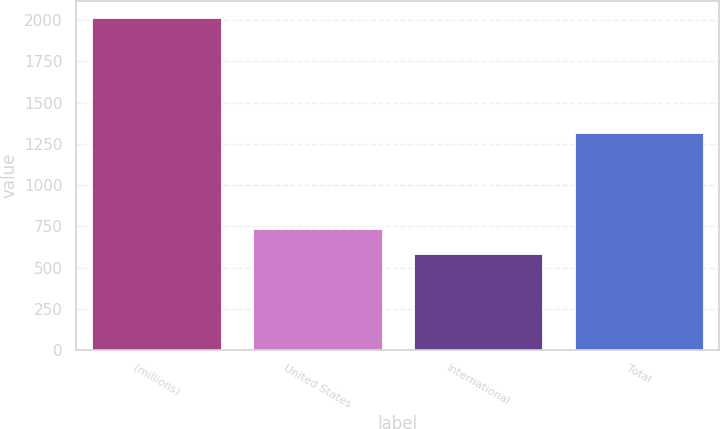Convert chart to OTSL. <chart><loc_0><loc_0><loc_500><loc_500><bar_chart><fcel>(millions)<fcel>United States<fcel>International<fcel>Total<nl><fcel>2015<fcel>733<fcel>584.7<fcel>1317.7<nl></chart> 